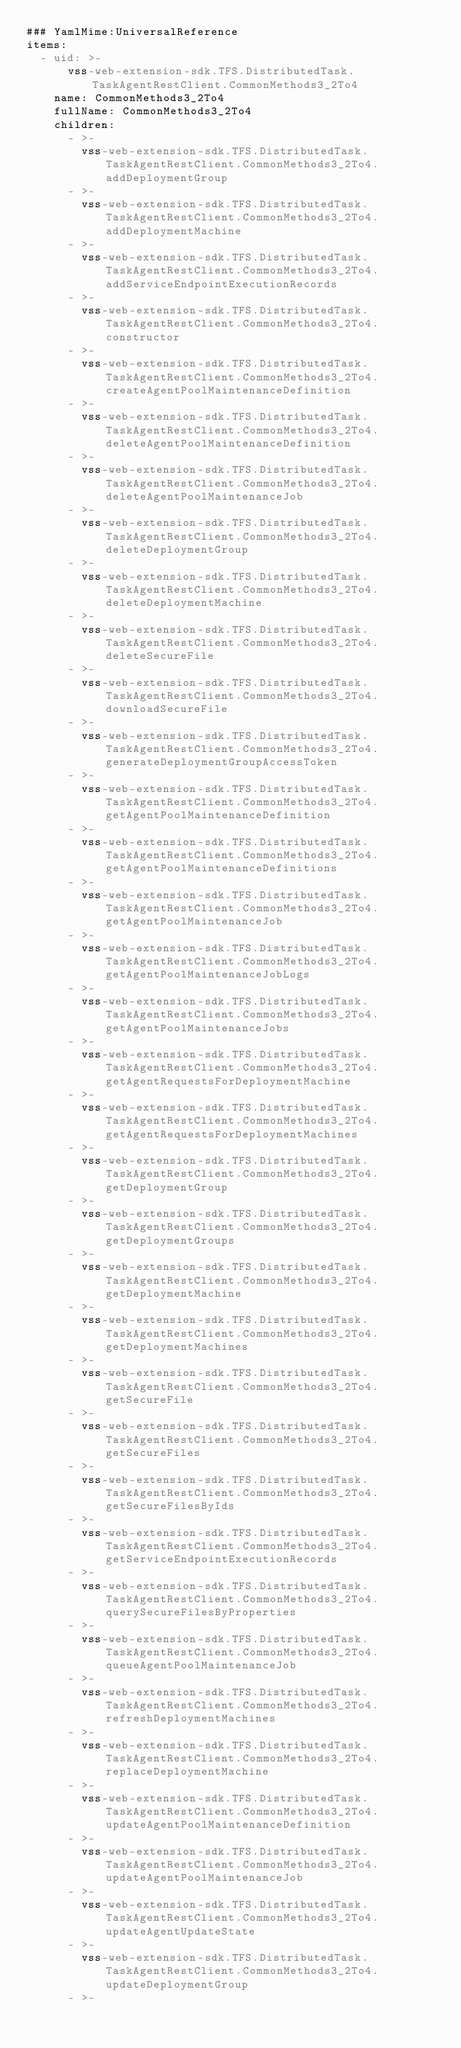<code> <loc_0><loc_0><loc_500><loc_500><_YAML_>### YamlMime:UniversalReference
items:
  - uid: >-
      vss-web-extension-sdk.TFS.DistributedTask.TaskAgentRestClient.CommonMethods3_2To4
    name: CommonMethods3_2To4
    fullName: CommonMethods3_2To4
    children:
      - >-
        vss-web-extension-sdk.TFS.DistributedTask.TaskAgentRestClient.CommonMethods3_2To4.addDeploymentGroup
      - >-
        vss-web-extension-sdk.TFS.DistributedTask.TaskAgentRestClient.CommonMethods3_2To4.addDeploymentMachine
      - >-
        vss-web-extension-sdk.TFS.DistributedTask.TaskAgentRestClient.CommonMethods3_2To4.addServiceEndpointExecutionRecords
      - >-
        vss-web-extension-sdk.TFS.DistributedTask.TaskAgentRestClient.CommonMethods3_2To4.constructor
      - >-
        vss-web-extension-sdk.TFS.DistributedTask.TaskAgentRestClient.CommonMethods3_2To4.createAgentPoolMaintenanceDefinition
      - >-
        vss-web-extension-sdk.TFS.DistributedTask.TaskAgentRestClient.CommonMethods3_2To4.deleteAgentPoolMaintenanceDefinition
      - >-
        vss-web-extension-sdk.TFS.DistributedTask.TaskAgentRestClient.CommonMethods3_2To4.deleteAgentPoolMaintenanceJob
      - >-
        vss-web-extension-sdk.TFS.DistributedTask.TaskAgentRestClient.CommonMethods3_2To4.deleteDeploymentGroup
      - >-
        vss-web-extension-sdk.TFS.DistributedTask.TaskAgentRestClient.CommonMethods3_2To4.deleteDeploymentMachine
      - >-
        vss-web-extension-sdk.TFS.DistributedTask.TaskAgentRestClient.CommonMethods3_2To4.deleteSecureFile
      - >-
        vss-web-extension-sdk.TFS.DistributedTask.TaskAgentRestClient.CommonMethods3_2To4.downloadSecureFile
      - >-
        vss-web-extension-sdk.TFS.DistributedTask.TaskAgentRestClient.CommonMethods3_2To4.generateDeploymentGroupAccessToken
      - >-
        vss-web-extension-sdk.TFS.DistributedTask.TaskAgentRestClient.CommonMethods3_2To4.getAgentPoolMaintenanceDefinition
      - >-
        vss-web-extension-sdk.TFS.DistributedTask.TaskAgentRestClient.CommonMethods3_2To4.getAgentPoolMaintenanceDefinitions
      - >-
        vss-web-extension-sdk.TFS.DistributedTask.TaskAgentRestClient.CommonMethods3_2To4.getAgentPoolMaintenanceJob
      - >-
        vss-web-extension-sdk.TFS.DistributedTask.TaskAgentRestClient.CommonMethods3_2To4.getAgentPoolMaintenanceJobLogs
      - >-
        vss-web-extension-sdk.TFS.DistributedTask.TaskAgentRestClient.CommonMethods3_2To4.getAgentPoolMaintenanceJobs
      - >-
        vss-web-extension-sdk.TFS.DistributedTask.TaskAgentRestClient.CommonMethods3_2To4.getAgentRequestsForDeploymentMachine
      - >-
        vss-web-extension-sdk.TFS.DistributedTask.TaskAgentRestClient.CommonMethods3_2To4.getAgentRequestsForDeploymentMachines
      - >-
        vss-web-extension-sdk.TFS.DistributedTask.TaskAgentRestClient.CommonMethods3_2To4.getDeploymentGroup
      - >-
        vss-web-extension-sdk.TFS.DistributedTask.TaskAgentRestClient.CommonMethods3_2To4.getDeploymentGroups
      - >-
        vss-web-extension-sdk.TFS.DistributedTask.TaskAgentRestClient.CommonMethods3_2To4.getDeploymentMachine
      - >-
        vss-web-extension-sdk.TFS.DistributedTask.TaskAgentRestClient.CommonMethods3_2To4.getDeploymentMachines
      - >-
        vss-web-extension-sdk.TFS.DistributedTask.TaskAgentRestClient.CommonMethods3_2To4.getSecureFile
      - >-
        vss-web-extension-sdk.TFS.DistributedTask.TaskAgentRestClient.CommonMethods3_2To4.getSecureFiles
      - >-
        vss-web-extension-sdk.TFS.DistributedTask.TaskAgentRestClient.CommonMethods3_2To4.getSecureFilesByIds
      - >-
        vss-web-extension-sdk.TFS.DistributedTask.TaskAgentRestClient.CommonMethods3_2To4.getServiceEndpointExecutionRecords
      - >-
        vss-web-extension-sdk.TFS.DistributedTask.TaskAgentRestClient.CommonMethods3_2To4.querySecureFilesByProperties
      - >-
        vss-web-extension-sdk.TFS.DistributedTask.TaskAgentRestClient.CommonMethods3_2To4.queueAgentPoolMaintenanceJob
      - >-
        vss-web-extension-sdk.TFS.DistributedTask.TaskAgentRestClient.CommonMethods3_2To4.refreshDeploymentMachines
      - >-
        vss-web-extension-sdk.TFS.DistributedTask.TaskAgentRestClient.CommonMethods3_2To4.replaceDeploymentMachine
      - >-
        vss-web-extension-sdk.TFS.DistributedTask.TaskAgentRestClient.CommonMethods3_2To4.updateAgentPoolMaintenanceDefinition
      - >-
        vss-web-extension-sdk.TFS.DistributedTask.TaskAgentRestClient.CommonMethods3_2To4.updateAgentPoolMaintenanceJob
      - >-
        vss-web-extension-sdk.TFS.DistributedTask.TaskAgentRestClient.CommonMethods3_2To4.updateAgentUpdateState
      - >-
        vss-web-extension-sdk.TFS.DistributedTask.TaskAgentRestClient.CommonMethods3_2To4.updateDeploymentGroup
      - >-</code> 